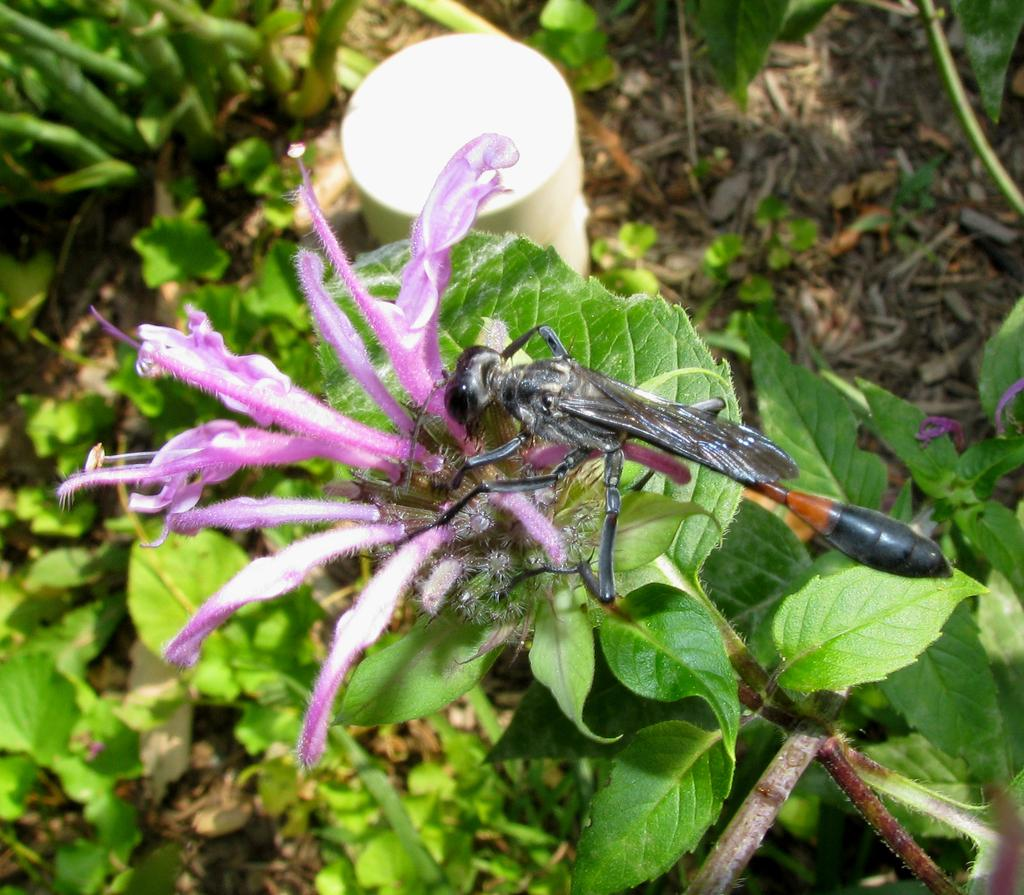What type of insect is present in the image? There is a damselfly in the image. What type of plant can be seen in the image? There is a flower in the image. What other natural elements are visible in the image? There are leaves in the image. What type of milk does the baby prefer in the image? There is no baby or milk present in the image. 